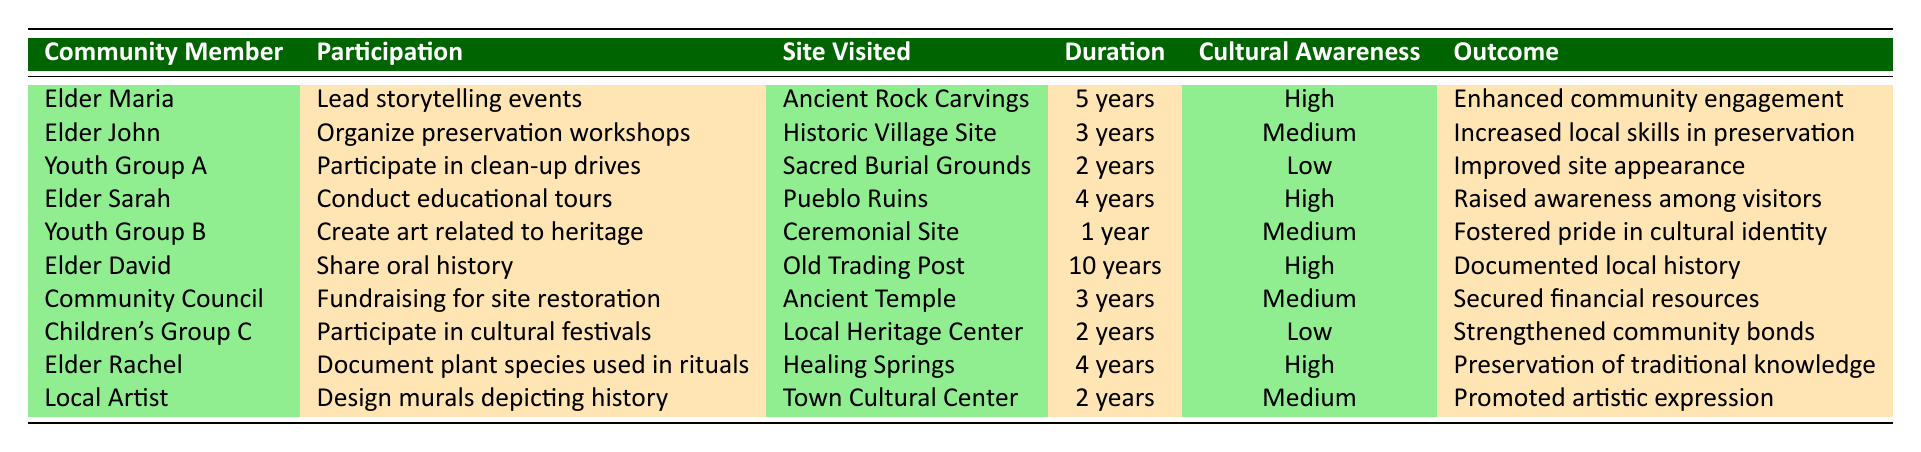What is the participation type of Elder Maria? Elder Maria's participation type can be directly found in the table under the "Participation" column for her name. She is listed as leading storytelling events.
Answer: Lead storytelling events How many years has Elder David participated in cultural preservation activities? The duration for Elder David is directly provided in the table. It states his participation lasted for 10 years.
Answer: 10 years Are there any community members with low cultural awareness? By scanning the "Cultural Awareness" column, both Youth Group A and Children's Group C are marked as having low cultural awareness. Thus, the answer to this question is yes.
Answer: Yes Which site was visited by the Community Council? The table shows the "Site Visited" for the Community Council under the respective column, indicating they visited the Ancient Temple.
Answer: Ancient Temple What is the outcome associated with Elder Sarah's participation? In the table, the "Outcome" linked with Elder Sarah's participation can be referenced, showing she raised awareness among visitors.
Answer: Raised awareness among visitors What is the average duration of participation for entries with high cultural awareness? We identify the members with high cultural awareness: Elder Maria (5 years), Elder Sarah (4 years), Elder David (10 years), and Elder Rachel (4 years). Summing these gives 5 + 4 + 10 + 4 = 23 years. There are 4 entries, so the average duration is 23 years / 4 = 5.75 years.
Answer: 5.75 years Do any youth groups have high cultural awareness? By examining the "Cultural Awareness" column for youth groups, both Youth Group A and Youth Group B are marked as low and medium, respectively. Therefore, neither has high cultural awareness.
Answer: No Which community member has the longest duration of participation, and what was their role? A careful review of the "Duration" column shows Elder David with 10 years of participation as the longest. His role was sharing oral history.
Answer: Elder David, sharing oral history What is the outcome of Youth Group B's activities? The table specifies that Youth Group B fostered pride in cultural identity as their outcome. This is found under the "Outcome" column for that group.
Answer: Fostered pride in cultural identity 